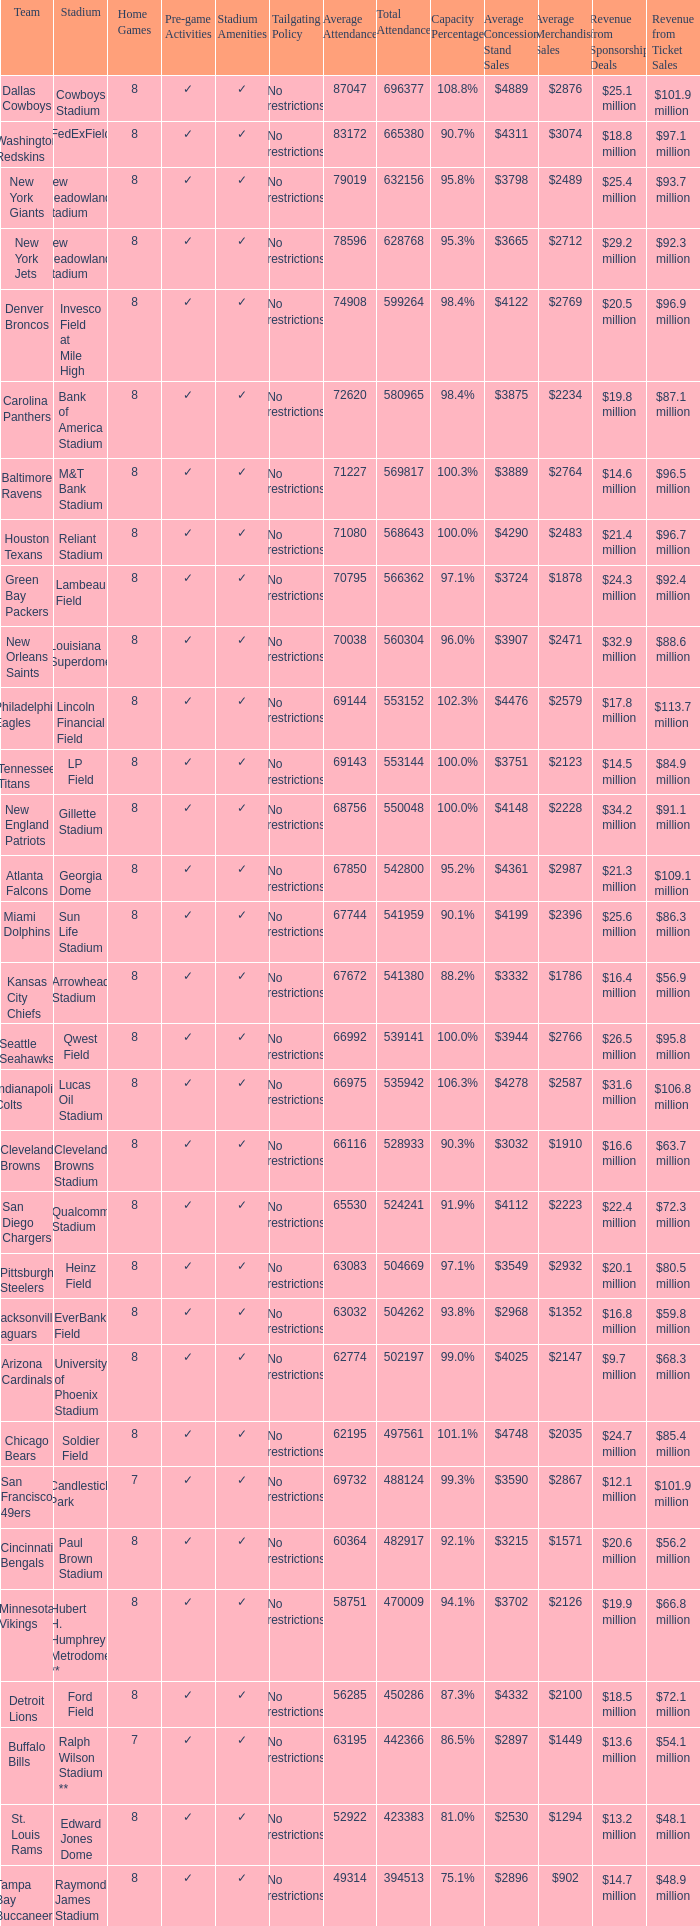What was the capacity percentage when attendance was 71080? 100.0%. 